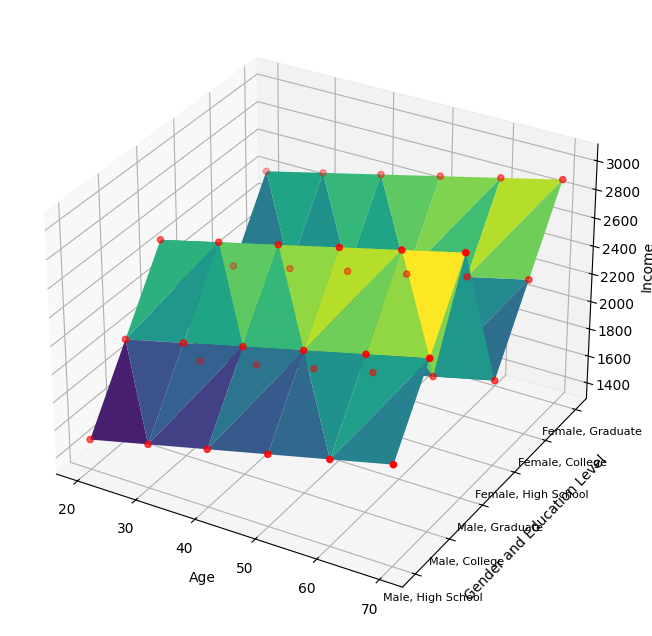What age group has the highest average income for graduates? To find the highest average income for graduates, compare the income values across all age groups for individuals who are graduates. Check the z-values (income) where the education level is 'Graduate'. The values are 2500, 2600, 2700, 2800, 2900, and 3000. The highest of these values is 3000, corresponding to the age 70 group.
Answer: 70 Which gender with a college degree has higher income at age 40? Identify the income values for age 40 for both males and females with a college degree. For age 40, college-educated males have an income of 2200, while college-educated females have an income of 2100. Compare these values. 2200 > 2100 thus males earn more.
Answer: Male By how much does the income of a 50-year-old high school educated male exceed that of a high school educated female of the same age? For high school education at age 50, the income values are 1800 for males and 1700 for females. Subtract the female income from the male income: 1800 - 1700 = 100.
Answer: 100 What is the income difference between males and females with a graduate degree at age 60? Find the income values at age 60 for males and females with a graduate degree. These values are 2900 for males and 2800 for females. Subtract the female income from the male income: 2900 - 2800 = 100.
Answer: 100 For college graduates, which age group has the lowest income? Identify the income values for all age groups for college graduates. These values are 2000, 2100, 2200, 2300, 2400, and 2500. The lowest value is 2000, which corresponds to the age 20 group.
Answer: 20 Is there any age group where females with a high school education have higher income than their male counterparts? Compare the income values for each age group for high school-educated males and females. No values show females surpassing males. Therefore, for every age group, female incomes are not higher than male incomes.
Answer: No What is the combined income for male graduates aged 30 and female graduates aged 40? Locate the income for male graduates at age 30 (2600) and female graduates at age 40 (2600). Sum these values: 2600 + 2600 = 5200.
Answer: 5200 What is the income difference between a 30-year-old college-educated female and a 60-year-old high school-educated male? Identify the incomes for a 30-year-old female with a college education (2000) and a 60-year-old male with high school education (1900). Compute the difference: 2000 - 1900 = 100.
Answer: 100 How does the income distribution for males progress with each education level at age 50? For males at age 50, find the incomes across the education levels: 1800 (High School), 2300 (College), and 2800 (Graduate). The income increases with higher education levels.
Answer: Increases Which education level shows a more significant income increase from age 40 to 50 for females? Compare the income values for females at age 40 and age 50 across education levels: High School 1600 to 1700, College 2100 to 2200, and Graduate 2600 to 2700. Each level shows an increase of 100, indicating that the income increase is equal for all education levels.
Answer: Equal 